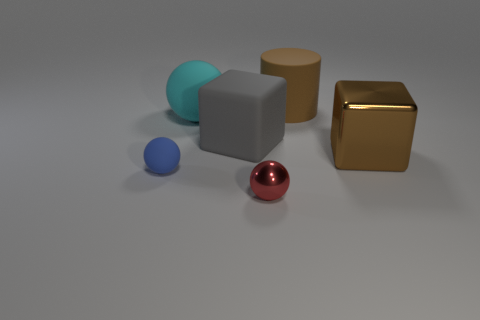The brown cube is what size?
Offer a terse response. Large. There is another metal object that is the same shape as the small blue thing; what is its size?
Offer a very short reply. Small. There is a big block that is left of the large brown rubber cylinder; how many small blue rubber balls are on the left side of it?
Ensure brevity in your answer.  1. Do the brown thing that is in front of the big brown cylinder and the ball behind the tiny rubber sphere have the same material?
Keep it short and to the point. No. What number of other things are the same shape as the red metal thing?
Make the answer very short. 2. What number of small shiny objects have the same color as the matte cylinder?
Give a very brief answer. 0. Does the big brown object that is in front of the cyan thing have the same shape as the big rubber thing that is in front of the cyan rubber sphere?
Keep it short and to the point. Yes. How many large gray objects are to the right of the rubber ball behind the large block left of the brown matte cylinder?
Your response must be concise. 1. There is a large cube behind the big object on the right side of the large brown object that is left of the large metal object; what is it made of?
Your answer should be very brief. Rubber. Do the sphere that is in front of the small blue ball and the big sphere have the same material?
Keep it short and to the point. No. 